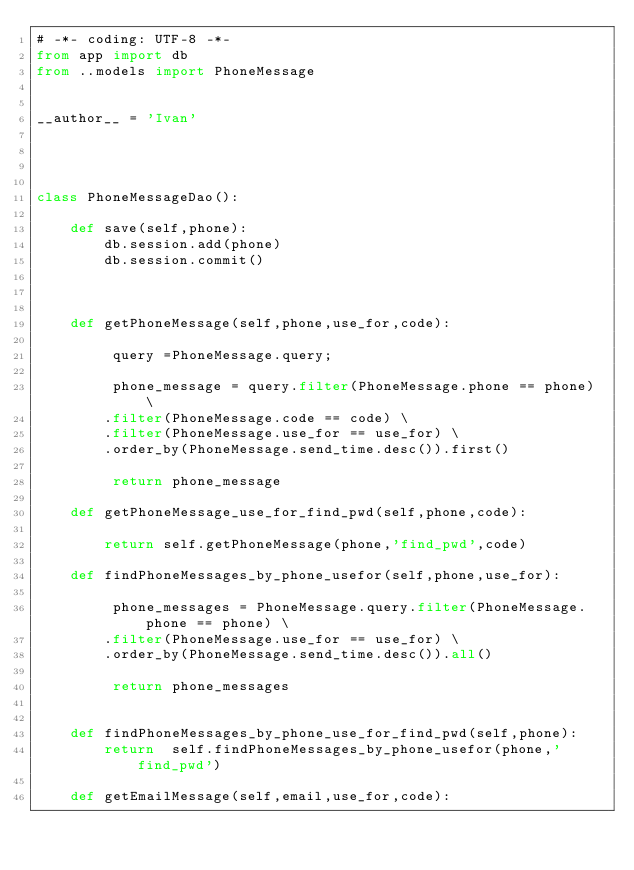<code> <loc_0><loc_0><loc_500><loc_500><_Python_># -*- coding: UTF-8 -*-
from app import db
from ..models import PhoneMessage


__author__ = 'Ivan'




class PhoneMessageDao():

    def save(self,phone):
        db.session.add(phone)
        db.session.commit()



    def getPhoneMessage(self,phone,use_for,code):

         query =PhoneMessage.query;

         phone_message = query.filter(PhoneMessage.phone == phone) \
        .filter(PhoneMessage.code == code) \
        .filter(PhoneMessage.use_for == use_for) \
        .order_by(PhoneMessage.send_time.desc()).first()

         return phone_message

    def getPhoneMessage_use_for_find_pwd(self,phone,code):

        return self.getPhoneMessage(phone,'find_pwd',code)

    def findPhoneMessages_by_phone_usefor(self,phone,use_for):

         phone_messages = PhoneMessage.query.filter(PhoneMessage.phone == phone) \
        .filter(PhoneMessage.use_for == use_for) \
        .order_by(PhoneMessage.send_time.desc()).all()

         return phone_messages


    def findPhoneMessages_by_phone_use_for_find_pwd(self,phone):
        return  self.findPhoneMessages_by_phone_usefor(phone,'find_pwd')

    def getEmailMessage(self,email,use_for,code):
</code> 